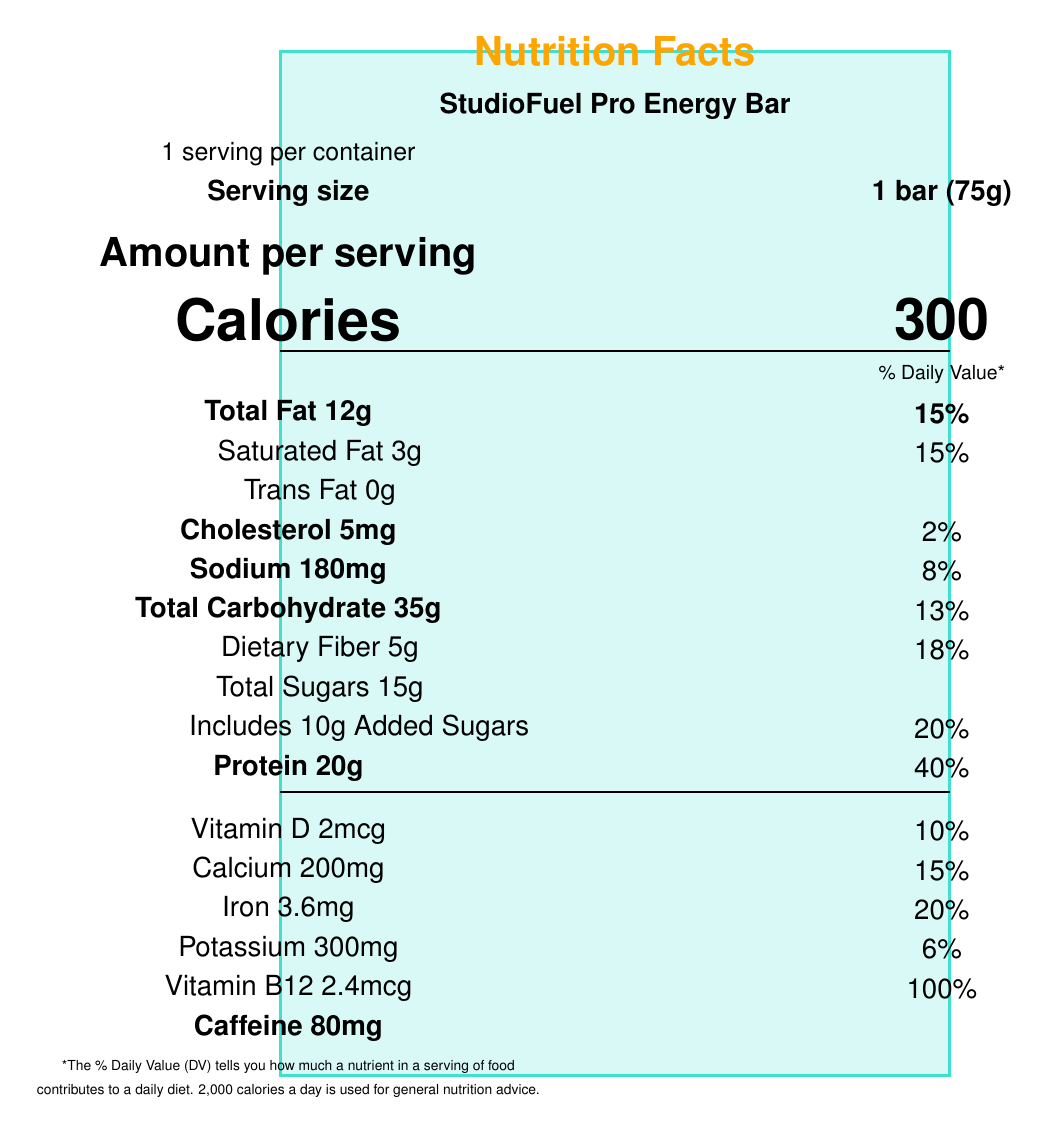what is the serving size? The serving size is clearly indicated as "1 bar (75g)" under the "Serving size" section.
Answer: 1 bar (75g) how many calories are in one serving? The number of calories per serving is prominently displayed under the "Calories" section.
Answer: 300 calories what is the total fat content per serving? The total fat content per serving is listed as "Total Fat 12g".
Answer: 12g how much protein does one bar contain? The protein content per bar is mentioned as "Protein 20g".
Answer: 20g what is the daily value percentage of vitamin B12? The daily value percentage for vitamin B12 is listed as 100%.
Answer: 100% how many grams of dietary fiber are in one serving? The dietary fiber content per serving is shown as "Dietary Fiber 5g".
Answer: 5g how much sodium does one bar contain? The sodium content per bar is listed as "Sodium 180mg".
Answer: 180mg which of the following ingredients is NOT present in the StudioFuel Pro Energy Bar? A. Whey protein isolate B. Peanuts C. Dried cranberries The ingredients list shows whey protein isolate and dried cranberries but does not include peanuts.
Answer: B what is the amount of caffeine in one bar? The caffeine content per bar is stated as "Caffeine 80mg" at the bottom of the nutritional information.
Answer: 80mg does the StudioFuel Pro Energy Bar contain any trans fat? The document indicates "Trans Fat 0g", meaning it contains no trans fat.
Answer: No what is the percentage of daily value for iron in one serving? The daily value percentage for iron is listed as 20%.
Answer: 20% how many servings are there per container? The document states "1 serving per container" and shows that one container has 12 servings.
Answer: 12 what is the total sugar content in one bar including added sugars (in grams)? The document states "Total Sugars 15g" and "Includes 10g Added Sugars" under the total carbohydrate section.
Answer: 15g what allergens are present in the StudioFuel Pro Energy Bar? The allergen information indicates that the bar contains milk and tree nuts (almonds) and is manufactured in a facility processing soy, peanuts, and wheat.
Answer: Contains milk and tree nuts (almonds). Manufactured in a facility that also processes soy, peanuts, and wheat. which of the following minerals has the highest daily value percentage in one bar? A. Calcium B. Iron C. Potassium Iron has the highest daily value percentage of 20% compared to calcium at 15% and potassium at 6%.
Answer: B. Iron what are some special features of the StudioFuel Pro Energy Bar? These special features are listed under the "special features" section.
Answer: Sustained energy release for long recording sessions, high in protein for muscle recovery, contains natural caffeine sources for mental alertness, rich in B-vitamins for cognitive function, gluten-free does the document provide information on where the product is manufactured? The document mentions that the product is manufactured by Harmony Nutrition Labs, Los Angeles, CA 90028.
Answer: Yes what should I do if I need more information about the manufacturing process? The document provides nutrition facts and manufacturing location, but does not detail the manufacturing process, so more specific inquiries would be needed outside of the document.
Answer: Not enough information 